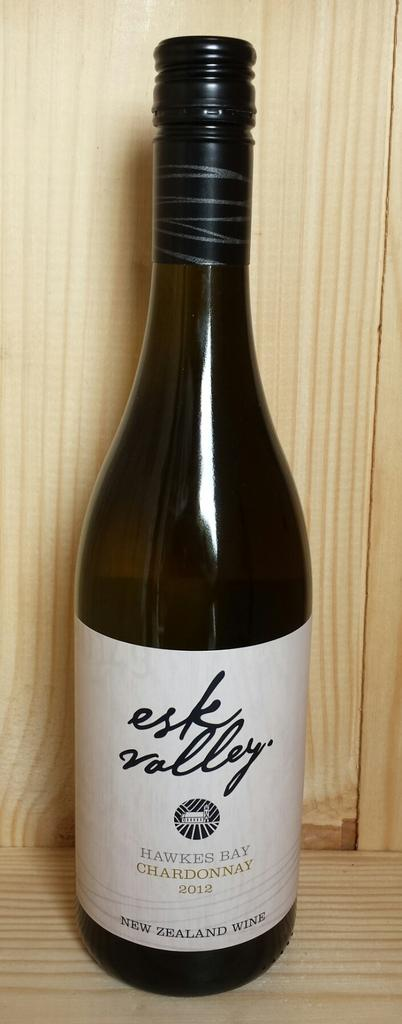<image>
Give a short and clear explanation of the subsequent image. A bottle of Esk Valley Chardonnay from 2012. 